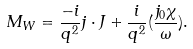<formula> <loc_0><loc_0><loc_500><loc_500>M _ { W } = \frac { - i } { q ^ { 2 } } j \cdot J + \frac { i } { q ^ { 2 } } ( \frac { j _ { 0 } \chi } { \omega } ) .</formula> 